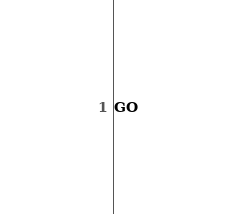<code> <loc_0><loc_0><loc_500><loc_500><_SQL_>GO</code> 